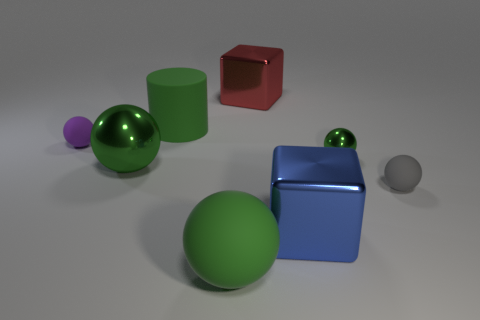What number of large rubber things are the same color as the tiny metal ball?
Make the answer very short. 2. There is a large matte ball; does it have the same color as the big rubber thing behind the small green object?
Your answer should be compact. Yes. There is a blue object that is made of the same material as the large red object; what is its shape?
Your response must be concise. Cube. What shape is the large object that is both to the right of the rubber cylinder and behind the small purple thing?
Offer a very short reply. Cube. Is the red object the same size as the gray rubber ball?
Provide a succinct answer. No. There is a rubber ball that is on the right side of the big metallic sphere and to the left of the tiny gray sphere; how big is it?
Your response must be concise. Large. Is there a big ball that is behind the large shiny object in front of the large ball behind the blue block?
Your response must be concise. Yes. Are any big spheres visible?
Offer a terse response. Yes. Are there more spheres on the right side of the purple thing than large blue metal objects that are in front of the big metallic sphere?
Your answer should be compact. Yes. What size is the green cylinder that is the same material as the purple sphere?
Offer a very short reply. Large. 